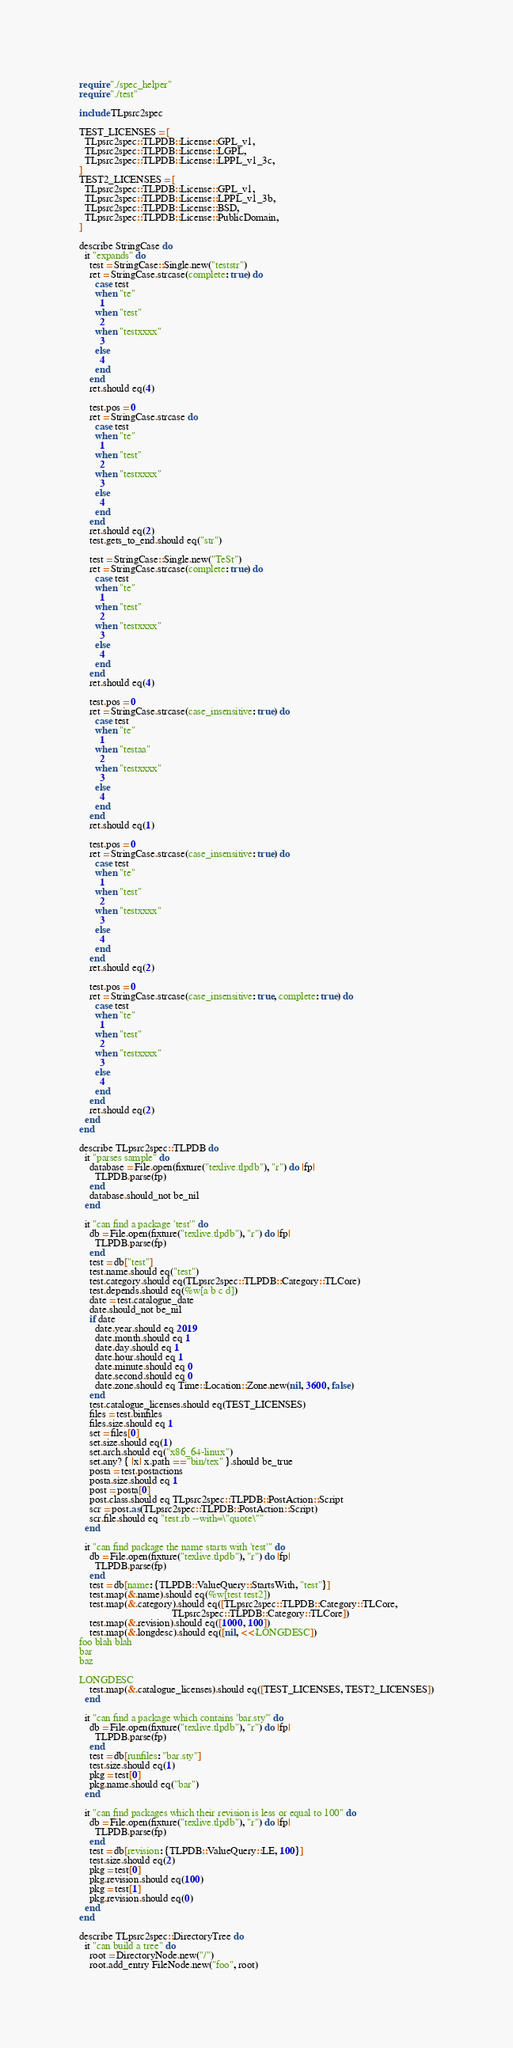Convert code to text. <code><loc_0><loc_0><loc_500><loc_500><_Crystal_>require "./spec_helper"
require "./test"

include TLpsrc2spec

TEST_LICENSES = [
  TLpsrc2spec::TLPDB::License::GPL_v1,
  TLpsrc2spec::TLPDB::License::LGPL,
  TLpsrc2spec::TLPDB::License::LPPL_v1_3c,
]
TEST2_LICENSES = [
  TLpsrc2spec::TLPDB::License::GPL_v1,
  TLpsrc2spec::TLPDB::License::LPPL_v1_3b,
  TLpsrc2spec::TLPDB::License::BSD,
  TLpsrc2spec::TLPDB::License::PublicDomain,
]

describe StringCase do
  it "expands" do
    test = StringCase::Single.new("teststr")
    ret = StringCase.strcase(complete: true) do
      case test
      when "te"
        1
      when "test"
        2
      when "testxxxx"
        3
      else
        4
      end
    end
    ret.should eq(4)

    test.pos = 0
    ret = StringCase.strcase do
      case test
      when "te"
        1
      when "test"
        2
      when "testxxxx"
        3
      else
        4
      end
    end
    ret.should eq(2)
    test.gets_to_end.should eq("str")

    test = StringCase::Single.new("TeSt")
    ret = StringCase.strcase(complete: true) do
      case test
      when "te"
        1
      when "test"
        2
      when "testxxxx"
        3
      else
        4
      end
    end
    ret.should eq(4)

    test.pos = 0
    ret = StringCase.strcase(case_insensitive: true) do
      case test
      when "te"
        1
      when "testaa"
        2
      when "testxxxx"
        3
      else
        4
      end
    end
    ret.should eq(1)

    test.pos = 0
    ret = StringCase.strcase(case_insensitive: true) do
      case test
      when "te"
        1
      when "test"
        2
      when "testxxxx"
        3
      else
        4
      end
    end
    ret.should eq(2)

    test.pos = 0
    ret = StringCase.strcase(case_insensitive: true, complete: true) do
      case test
      when "te"
        1
      when "test"
        2
      when "testxxxx"
        3
      else
        4
      end
    end
    ret.should eq(2)
  end
end

describe TLpsrc2spec::TLPDB do
  it "parses sample" do
    database = File.open(fixture("texlive.tlpdb"), "r") do |fp|
      TLPDB.parse(fp)
    end
    database.should_not be_nil
  end

  it "can find a package 'test'" do
    db = File.open(fixture("texlive.tlpdb"), "r") do |fp|
      TLPDB.parse(fp)
    end
    test = db["test"]
    test.name.should eq("test")
    test.category.should eq(TLpsrc2spec::TLPDB::Category::TLCore)
    test.depends.should eq(%w[a b c d])
    date = test.catalogue_date
    date.should_not be_nil
    if date
      date.year.should eq 2019
      date.month.should eq 1
      date.day.should eq 1
      date.hour.should eq 1
      date.minute.should eq 0
      date.second.should eq 0
      date.zone.should eq Time::Location::Zone.new(nil, 3600, false)
    end
    test.catalogue_licenses.should eq(TEST_LICENSES)
    files = test.binfiles
    files.size.should eq 1
    set = files[0]
    set.size.should eq(1)
    set.arch.should eq("x86_64-linux")
    set.any? { |x| x.path == "bin/tex" }.should be_true
    posta = test.postactions
    posta.size.should eq 1
    post = posta[0]
    post.class.should eq TLpsrc2spec::TLPDB::PostAction::Script
    scr = post.as(TLpsrc2spec::TLPDB::PostAction::Script)
    scr.file.should eq "test.rb --with=\"quote\""
  end

  it "can find package the name starts with 'test'" do
    db = File.open(fixture("texlive.tlpdb"), "r") do |fp|
      TLPDB.parse(fp)
    end
    test = db[name: {TLPDB::ValueQuery::StartsWith, "test"}]
    test.map(&.name).should eq(%w[test test2])
    test.map(&.category).should eq([TLpsrc2spec::TLPDB::Category::TLCore,
                                    TLpsrc2spec::TLPDB::Category::TLCore])
    test.map(&.revision).should eq([1000, 100])
    test.map(&.longdesc).should eq([nil, <<-LONGDESC])
foo blah blah
bar
baz

LONGDESC
    test.map(&.catalogue_licenses).should eq([TEST_LICENSES, TEST2_LICENSES])
  end

  it "can find a package which contains 'bar.sty'" do
    db = File.open(fixture("texlive.tlpdb"), "r") do |fp|
      TLPDB.parse(fp)
    end
    test = db[runfiles: "bar.sty"]
    test.size.should eq(1)
    pkg = test[0]
    pkg.name.should eq("bar")
  end

  it "can find packages which their revision is less or equal to 100" do
    db = File.open(fixture("texlive.tlpdb"), "r") do |fp|
      TLPDB.parse(fp)
    end
    test = db[revision: {TLPDB::ValueQuery::LE, 100}]
    test.size.should eq(2)
    pkg = test[0]
    pkg.revision.should eq(100)
    pkg = test[1]
    pkg.revision.should eq(0)
  end
end

describe TLpsrc2spec::DirectoryTree do
  it "can build a tree" do
    root = DirectoryNode.new("/")
    root.add_entry FileNode.new("foo", root)</code> 